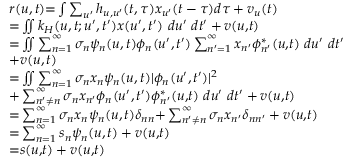<formula> <loc_0><loc_0><loc_500><loc_500>\begin{array} { r l } & { r ( u , t ) { = } \int \sum _ { u ^ { \prime } } h _ { u , u ^ { \prime } } ( t , \tau ) x _ { u ^ { \prime } } ( t - \tau ) d \tau + v _ { u } ( t ) } \\ & { { = } \iint k _ { H } ( u , t ; u ^ { \prime } , t ^ { \prime } ) x ( u ^ { \prime } , t ^ { \prime } ) d u ^ { \prime } d t ^ { \prime } + v ( u { , } t ) } \\ & { { = } \iint \sum _ { n { = 1 } } ^ { \infty } \sigma _ { n } \psi _ { n } ( u , t ) \phi _ { n } ( u ^ { \prime } , t ^ { \prime } ) \sum _ { n ^ { \prime } { = } 1 } ^ { \infty } x _ { n ^ { \prime } } \phi _ { n ^ { \prime } } ^ { * } ( u { , } t ) d u ^ { \prime } d t ^ { \prime } } \\ & { { + } v ( u , t ) } \\ & { { = } \iint \sum _ { n { = 1 } } ^ { \infty } \sigma _ { n } x _ { n } \psi _ { n } ( u , t ) | \phi _ { n } ( u ^ { \prime } , t ^ { \prime } ) | ^ { 2 } } \\ & { { + } \sum _ { n ^ { \prime } { \neq } n } ^ { \infty } \sigma _ { n } x _ { n ^ { \prime } } \phi _ { n } ( u ^ { \prime } , t ^ { \prime } ) \phi _ { n ^ { \prime } } ^ { * } ( u { , } t ) d u ^ { \prime } d t ^ { \prime } + v ( u { , } t ) } \\ & { { = } \sum _ { n { = 1 } } ^ { \infty } \sigma _ { n } x _ { n } \psi _ { n } ( u , t ) \delta _ { n n } { + } \sum _ { n ^ { \prime } { \neq } n } ^ { \infty } \sigma _ { n } x _ { n ^ { \prime } } \delta _ { n n ^ { \prime } } + v ( u { , } t ) } \\ & { { = } \sum _ { n { = 1 } } ^ { \infty } s _ { n } \psi _ { n } ( u , t ) + v ( u { , } t ) } \\ & { { = } s ( u { , } t ) + v ( u { , } t ) } \end{array}</formula> 